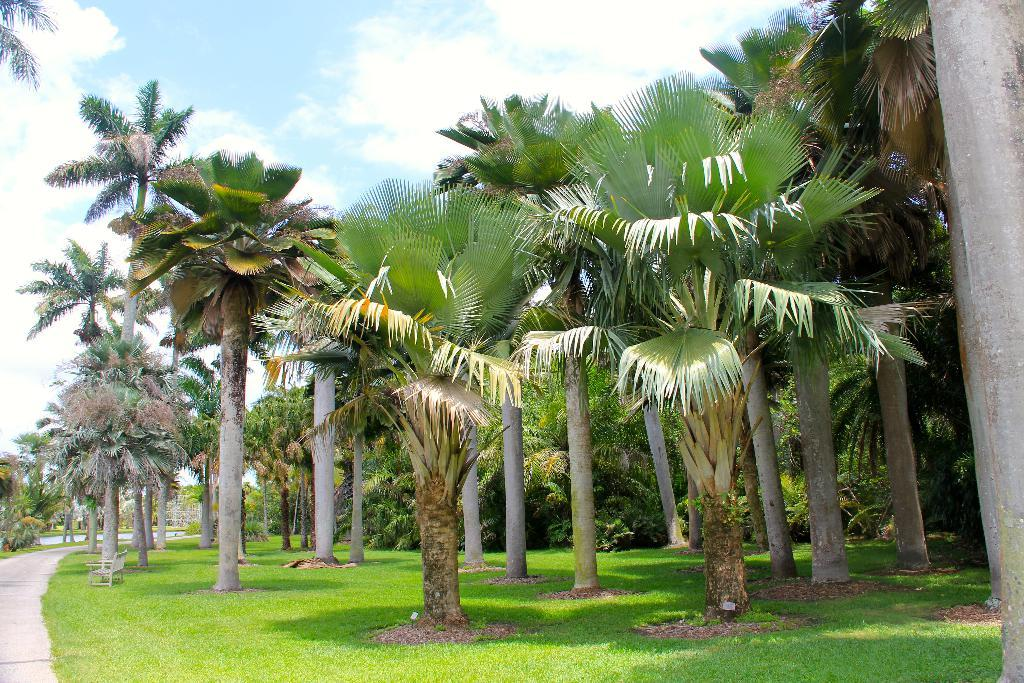What type of vegetation can be seen in the image? There are trees in the image. What else can be seen on the ground in the image? There is grass in the image. What is the surface that the trees and grass are growing on? The ground is visible in the image. What is present for people to sit on in the image? There is a bench in the image. What can be seen above the trees and bench in the image? The sky is visible in the image. What page of the book is the person reading while sitting on the bench in the image? There is no person or book present in the image, so it is not possible to determine which page they might be reading. 